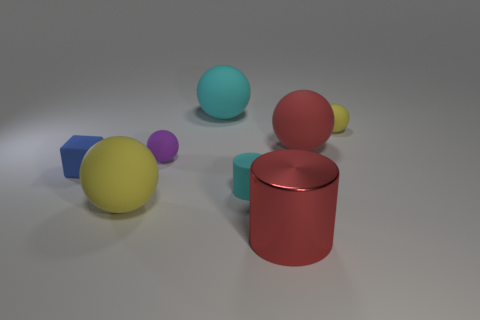Add 1 small cyan matte cylinders. How many objects exist? 9 Subtract all spheres. How many objects are left? 3 Subtract all brown shiny blocks. Subtract all big red matte objects. How many objects are left? 7 Add 6 purple matte things. How many purple matte things are left? 7 Add 2 purple things. How many purple things exist? 3 Subtract 0 gray cylinders. How many objects are left? 8 